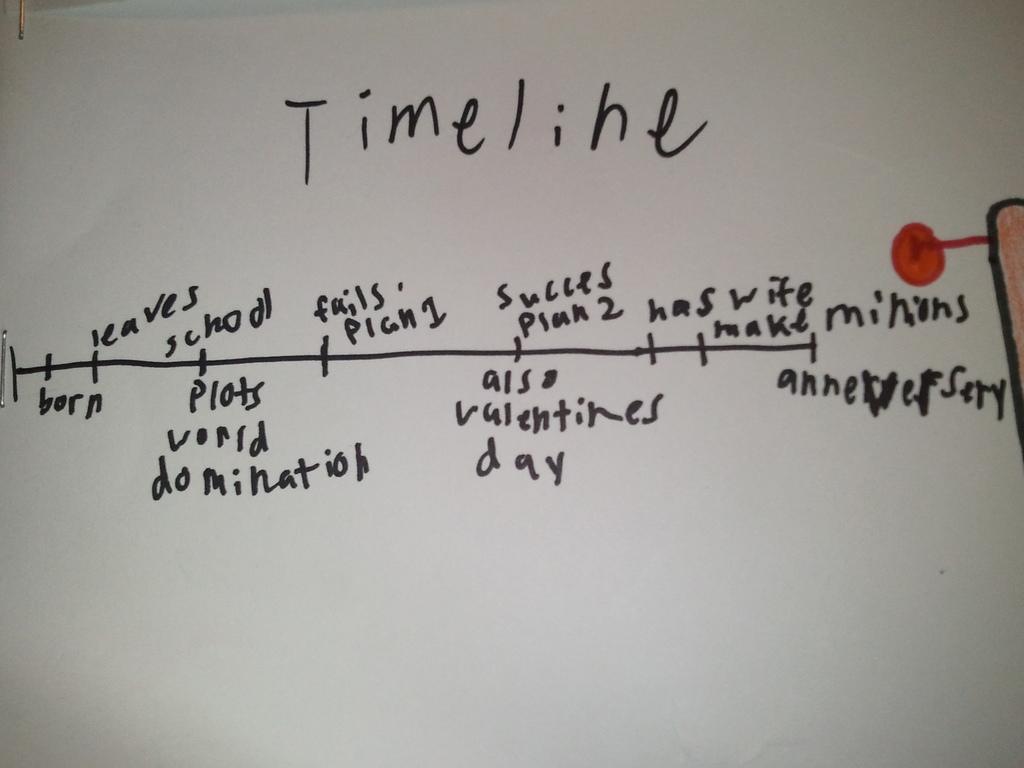Can you describe this image briefly? In this image I can see white colour thing and on it I can see something is written in black colour. I can also see a red colour dot over here. 